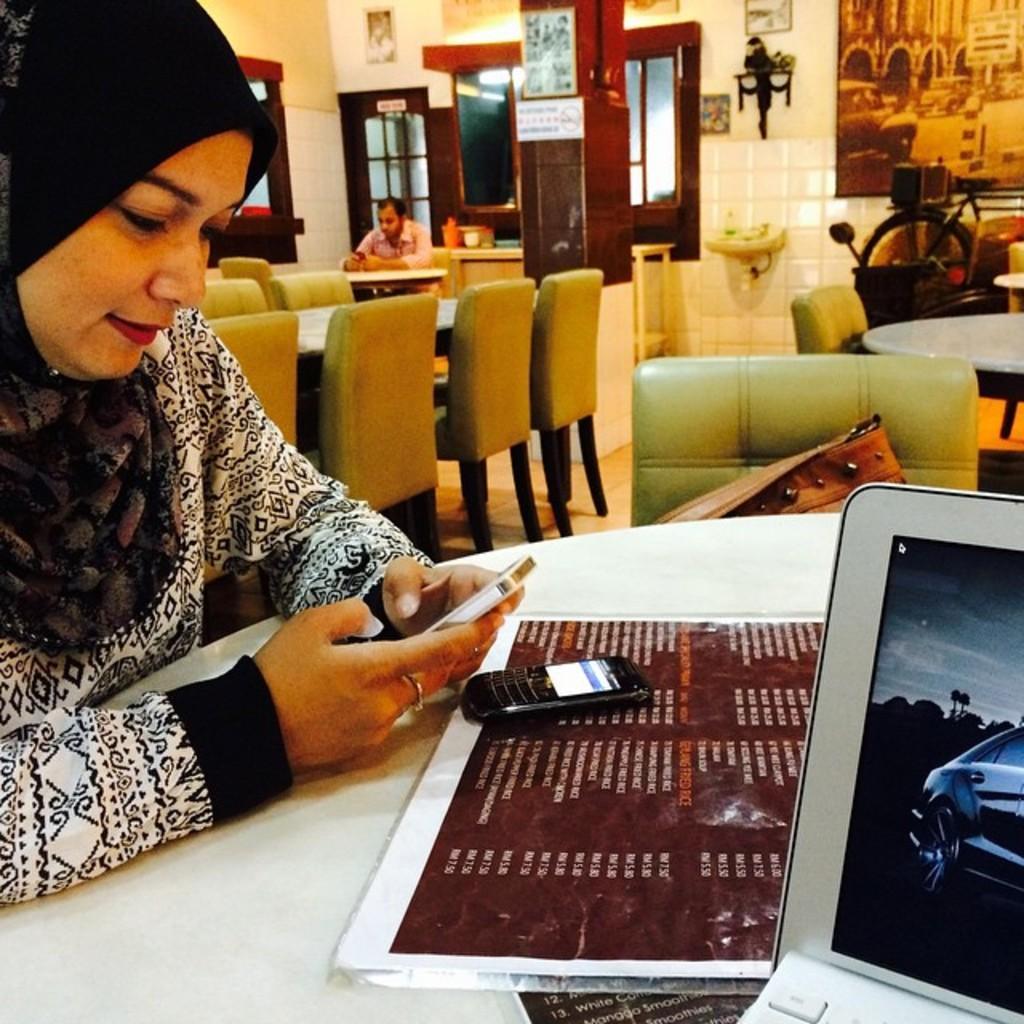Could you give a brief overview of what you see in this image? In this image I can see a woman sitting. There are mobile phones, laptop and menu on a white table. There are chairs and a person is sitting at the back. There is a door, window and photo frame at the back. 